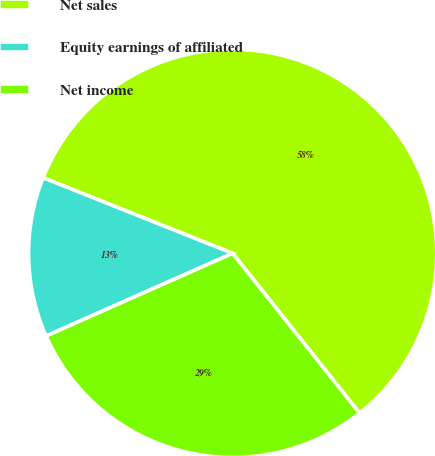<chart> <loc_0><loc_0><loc_500><loc_500><pie_chart><fcel>Net sales<fcel>Equity earnings of affiliated<fcel>Net income<nl><fcel>58.28%<fcel>12.68%<fcel>29.04%<nl></chart> 